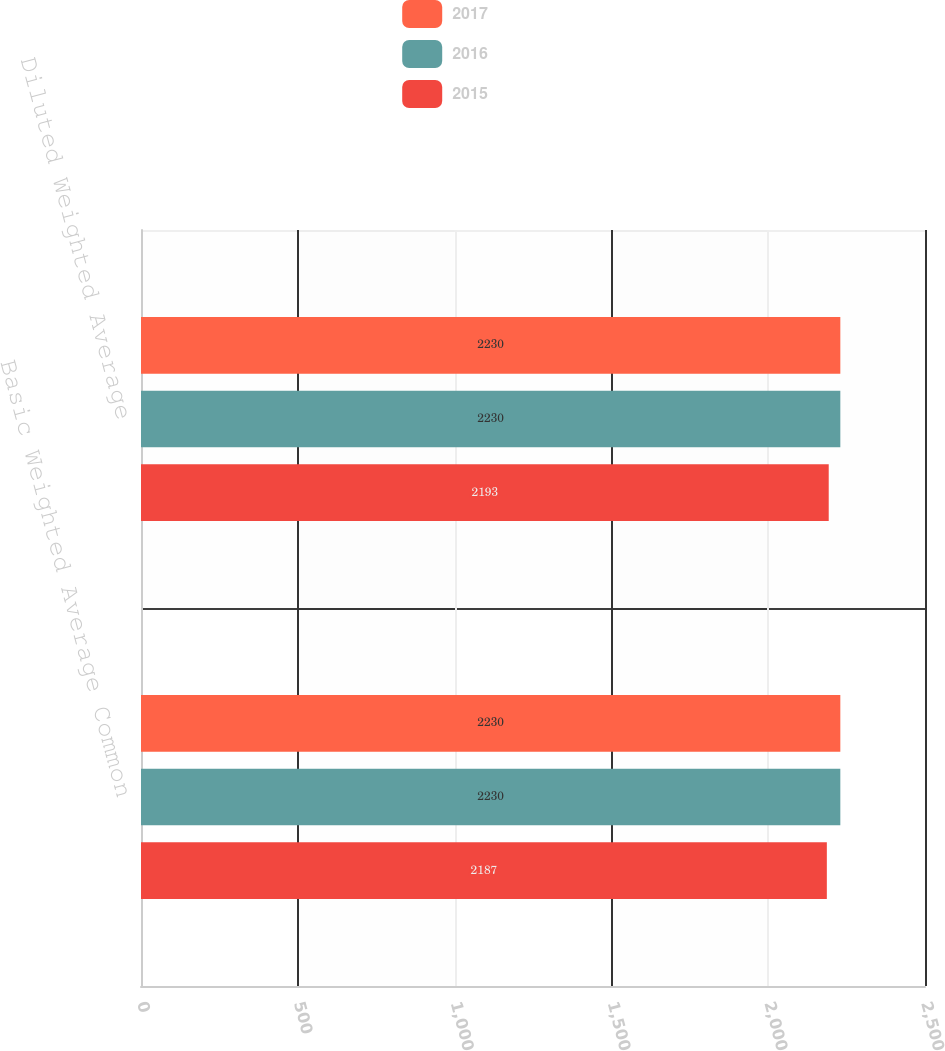Convert chart to OTSL. <chart><loc_0><loc_0><loc_500><loc_500><stacked_bar_chart><ecel><fcel>Basic Weighted Average Common<fcel>Diluted Weighted Average<nl><fcel>2017<fcel>2230<fcel>2230<nl><fcel>2016<fcel>2230<fcel>2230<nl><fcel>2015<fcel>2187<fcel>2193<nl></chart> 